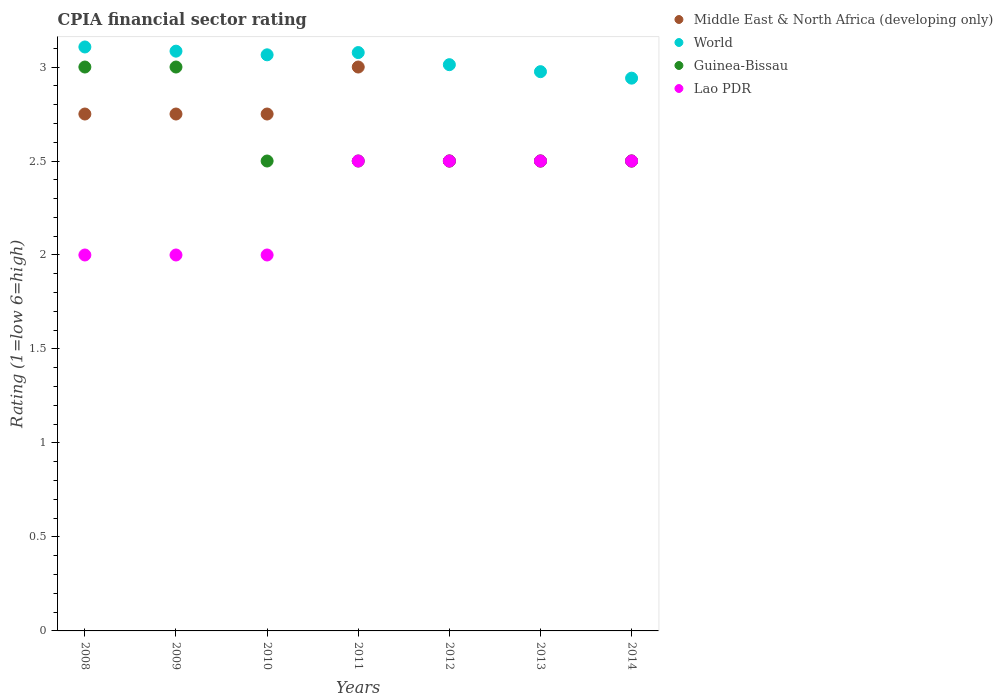How many different coloured dotlines are there?
Your answer should be very brief. 4. Is the number of dotlines equal to the number of legend labels?
Offer a very short reply. Yes. What is the CPIA rating in Lao PDR in 2013?
Provide a succinct answer. 2.5. Across all years, what is the maximum CPIA rating in Guinea-Bissau?
Make the answer very short. 3. Across all years, what is the minimum CPIA rating in Middle East & North Africa (developing only)?
Provide a short and direct response. 2.5. In which year was the CPIA rating in World maximum?
Provide a succinct answer. 2008. In which year was the CPIA rating in Middle East & North Africa (developing only) minimum?
Make the answer very short. 2012. What is the total CPIA rating in Middle East & North Africa (developing only) in the graph?
Ensure brevity in your answer.  18.75. What is the difference between the CPIA rating in Middle East & North Africa (developing only) in 2011 and that in 2014?
Ensure brevity in your answer.  0.5. What is the difference between the CPIA rating in Lao PDR in 2011 and the CPIA rating in Middle East & North Africa (developing only) in 2010?
Make the answer very short. -0.25. What is the average CPIA rating in Lao PDR per year?
Ensure brevity in your answer.  2.29. In the year 2014, what is the difference between the CPIA rating in World and CPIA rating in Lao PDR?
Make the answer very short. 0.44. What is the ratio of the CPIA rating in Guinea-Bissau in 2009 to that in 2011?
Make the answer very short. 1.2. Is the CPIA rating in World in 2009 less than that in 2013?
Provide a succinct answer. No. What is the difference between the highest and the second highest CPIA rating in Lao PDR?
Offer a terse response. 0. What is the difference between the highest and the lowest CPIA rating in Guinea-Bissau?
Offer a terse response. 0.5. Is the CPIA rating in World strictly less than the CPIA rating in Guinea-Bissau over the years?
Offer a very short reply. No. Are the values on the major ticks of Y-axis written in scientific E-notation?
Your response must be concise. No. Where does the legend appear in the graph?
Ensure brevity in your answer.  Top right. What is the title of the graph?
Your response must be concise. CPIA financial sector rating. Does "South Africa" appear as one of the legend labels in the graph?
Keep it short and to the point. No. What is the label or title of the X-axis?
Your response must be concise. Years. What is the label or title of the Y-axis?
Your answer should be very brief. Rating (1=low 6=high). What is the Rating (1=low 6=high) of Middle East & North Africa (developing only) in 2008?
Give a very brief answer. 2.75. What is the Rating (1=low 6=high) in World in 2008?
Ensure brevity in your answer.  3.11. What is the Rating (1=low 6=high) of Guinea-Bissau in 2008?
Your response must be concise. 3. What is the Rating (1=low 6=high) in Lao PDR in 2008?
Offer a very short reply. 2. What is the Rating (1=low 6=high) of Middle East & North Africa (developing only) in 2009?
Keep it short and to the point. 2.75. What is the Rating (1=low 6=high) in World in 2009?
Give a very brief answer. 3.08. What is the Rating (1=low 6=high) in Middle East & North Africa (developing only) in 2010?
Provide a short and direct response. 2.75. What is the Rating (1=low 6=high) in World in 2010?
Give a very brief answer. 3.06. What is the Rating (1=low 6=high) of Lao PDR in 2010?
Your answer should be very brief. 2. What is the Rating (1=low 6=high) of World in 2011?
Your answer should be compact. 3.08. What is the Rating (1=low 6=high) in World in 2012?
Your response must be concise. 3.01. What is the Rating (1=low 6=high) in Middle East & North Africa (developing only) in 2013?
Your answer should be compact. 2.5. What is the Rating (1=low 6=high) in World in 2013?
Provide a succinct answer. 2.98. What is the Rating (1=low 6=high) in Guinea-Bissau in 2013?
Offer a very short reply. 2.5. What is the Rating (1=low 6=high) of Lao PDR in 2013?
Offer a terse response. 2.5. What is the Rating (1=low 6=high) of Middle East & North Africa (developing only) in 2014?
Your answer should be compact. 2.5. What is the Rating (1=low 6=high) in World in 2014?
Your answer should be very brief. 2.94. What is the Rating (1=low 6=high) in Guinea-Bissau in 2014?
Your answer should be very brief. 2.5. Across all years, what is the maximum Rating (1=low 6=high) in Middle East & North Africa (developing only)?
Provide a succinct answer. 3. Across all years, what is the maximum Rating (1=low 6=high) in World?
Keep it short and to the point. 3.11. Across all years, what is the maximum Rating (1=low 6=high) of Guinea-Bissau?
Keep it short and to the point. 3. Across all years, what is the minimum Rating (1=low 6=high) in World?
Offer a terse response. 2.94. Across all years, what is the minimum Rating (1=low 6=high) in Lao PDR?
Give a very brief answer. 2. What is the total Rating (1=low 6=high) of Middle East & North Africa (developing only) in the graph?
Offer a very short reply. 18.75. What is the total Rating (1=low 6=high) in World in the graph?
Offer a very short reply. 21.26. What is the total Rating (1=low 6=high) of Lao PDR in the graph?
Keep it short and to the point. 16. What is the difference between the Rating (1=low 6=high) of World in 2008 and that in 2009?
Ensure brevity in your answer.  0.02. What is the difference between the Rating (1=low 6=high) in Middle East & North Africa (developing only) in 2008 and that in 2010?
Offer a very short reply. 0. What is the difference between the Rating (1=low 6=high) of World in 2008 and that in 2010?
Offer a terse response. 0.04. What is the difference between the Rating (1=low 6=high) of Guinea-Bissau in 2008 and that in 2010?
Keep it short and to the point. 0.5. What is the difference between the Rating (1=low 6=high) in Lao PDR in 2008 and that in 2010?
Provide a succinct answer. 0. What is the difference between the Rating (1=low 6=high) of Middle East & North Africa (developing only) in 2008 and that in 2011?
Provide a short and direct response. -0.25. What is the difference between the Rating (1=low 6=high) in World in 2008 and that in 2011?
Your answer should be very brief. 0.03. What is the difference between the Rating (1=low 6=high) in Guinea-Bissau in 2008 and that in 2011?
Give a very brief answer. 0.5. What is the difference between the Rating (1=low 6=high) in Middle East & North Africa (developing only) in 2008 and that in 2012?
Ensure brevity in your answer.  0.25. What is the difference between the Rating (1=low 6=high) in World in 2008 and that in 2012?
Provide a short and direct response. 0.09. What is the difference between the Rating (1=low 6=high) in Middle East & North Africa (developing only) in 2008 and that in 2013?
Make the answer very short. 0.25. What is the difference between the Rating (1=low 6=high) in World in 2008 and that in 2013?
Provide a succinct answer. 0.13. What is the difference between the Rating (1=low 6=high) of Lao PDR in 2008 and that in 2013?
Ensure brevity in your answer.  -0.5. What is the difference between the Rating (1=low 6=high) in World in 2008 and that in 2014?
Keep it short and to the point. 0.17. What is the difference between the Rating (1=low 6=high) in Lao PDR in 2008 and that in 2014?
Keep it short and to the point. -0.5. What is the difference between the Rating (1=low 6=high) of Middle East & North Africa (developing only) in 2009 and that in 2010?
Keep it short and to the point. 0. What is the difference between the Rating (1=low 6=high) in World in 2009 and that in 2010?
Your answer should be compact. 0.02. What is the difference between the Rating (1=low 6=high) of Middle East & North Africa (developing only) in 2009 and that in 2011?
Provide a short and direct response. -0.25. What is the difference between the Rating (1=low 6=high) in World in 2009 and that in 2011?
Provide a short and direct response. 0.01. What is the difference between the Rating (1=low 6=high) in World in 2009 and that in 2012?
Make the answer very short. 0.07. What is the difference between the Rating (1=low 6=high) in Lao PDR in 2009 and that in 2012?
Your answer should be very brief. -0.5. What is the difference between the Rating (1=low 6=high) in Middle East & North Africa (developing only) in 2009 and that in 2013?
Your answer should be very brief. 0.25. What is the difference between the Rating (1=low 6=high) of World in 2009 and that in 2013?
Provide a short and direct response. 0.11. What is the difference between the Rating (1=low 6=high) in World in 2009 and that in 2014?
Provide a succinct answer. 0.14. What is the difference between the Rating (1=low 6=high) in Guinea-Bissau in 2009 and that in 2014?
Ensure brevity in your answer.  0.5. What is the difference between the Rating (1=low 6=high) in Middle East & North Africa (developing only) in 2010 and that in 2011?
Offer a very short reply. -0.25. What is the difference between the Rating (1=low 6=high) of World in 2010 and that in 2011?
Your answer should be compact. -0.01. What is the difference between the Rating (1=low 6=high) of Lao PDR in 2010 and that in 2011?
Keep it short and to the point. -0.5. What is the difference between the Rating (1=low 6=high) in Middle East & North Africa (developing only) in 2010 and that in 2012?
Your answer should be compact. 0.25. What is the difference between the Rating (1=low 6=high) of World in 2010 and that in 2012?
Make the answer very short. 0.05. What is the difference between the Rating (1=low 6=high) in Lao PDR in 2010 and that in 2012?
Provide a succinct answer. -0.5. What is the difference between the Rating (1=low 6=high) of Middle East & North Africa (developing only) in 2010 and that in 2013?
Offer a very short reply. 0.25. What is the difference between the Rating (1=low 6=high) of World in 2010 and that in 2013?
Offer a terse response. 0.09. What is the difference between the Rating (1=low 6=high) of Guinea-Bissau in 2010 and that in 2013?
Your answer should be very brief. 0. What is the difference between the Rating (1=low 6=high) in Middle East & North Africa (developing only) in 2010 and that in 2014?
Provide a short and direct response. 0.25. What is the difference between the Rating (1=low 6=high) of World in 2010 and that in 2014?
Provide a short and direct response. 0.12. What is the difference between the Rating (1=low 6=high) of Lao PDR in 2010 and that in 2014?
Offer a very short reply. -0.5. What is the difference between the Rating (1=low 6=high) in Middle East & North Africa (developing only) in 2011 and that in 2012?
Offer a terse response. 0.5. What is the difference between the Rating (1=low 6=high) of World in 2011 and that in 2012?
Offer a terse response. 0.06. What is the difference between the Rating (1=low 6=high) in Guinea-Bissau in 2011 and that in 2012?
Keep it short and to the point. 0. What is the difference between the Rating (1=low 6=high) of Middle East & North Africa (developing only) in 2011 and that in 2013?
Ensure brevity in your answer.  0.5. What is the difference between the Rating (1=low 6=high) of World in 2011 and that in 2013?
Provide a succinct answer. 0.1. What is the difference between the Rating (1=low 6=high) of Guinea-Bissau in 2011 and that in 2013?
Your response must be concise. 0. What is the difference between the Rating (1=low 6=high) of Lao PDR in 2011 and that in 2013?
Provide a short and direct response. 0. What is the difference between the Rating (1=low 6=high) of Middle East & North Africa (developing only) in 2011 and that in 2014?
Ensure brevity in your answer.  0.5. What is the difference between the Rating (1=low 6=high) in World in 2011 and that in 2014?
Your response must be concise. 0.14. What is the difference between the Rating (1=low 6=high) of Guinea-Bissau in 2011 and that in 2014?
Offer a very short reply. 0. What is the difference between the Rating (1=low 6=high) in World in 2012 and that in 2013?
Give a very brief answer. 0.04. What is the difference between the Rating (1=low 6=high) in Guinea-Bissau in 2012 and that in 2013?
Keep it short and to the point. 0. What is the difference between the Rating (1=low 6=high) in Lao PDR in 2012 and that in 2013?
Make the answer very short. 0. What is the difference between the Rating (1=low 6=high) in World in 2012 and that in 2014?
Your answer should be compact. 0.07. What is the difference between the Rating (1=low 6=high) of Guinea-Bissau in 2012 and that in 2014?
Your answer should be compact. 0. What is the difference between the Rating (1=low 6=high) of Lao PDR in 2012 and that in 2014?
Your answer should be very brief. 0. What is the difference between the Rating (1=low 6=high) of World in 2013 and that in 2014?
Your response must be concise. 0.03. What is the difference between the Rating (1=low 6=high) in Middle East & North Africa (developing only) in 2008 and the Rating (1=low 6=high) in World in 2009?
Make the answer very short. -0.33. What is the difference between the Rating (1=low 6=high) of Middle East & North Africa (developing only) in 2008 and the Rating (1=low 6=high) of Guinea-Bissau in 2009?
Provide a succinct answer. -0.25. What is the difference between the Rating (1=low 6=high) in World in 2008 and the Rating (1=low 6=high) in Guinea-Bissau in 2009?
Provide a succinct answer. 0.11. What is the difference between the Rating (1=low 6=high) in World in 2008 and the Rating (1=low 6=high) in Lao PDR in 2009?
Your response must be concise. 1.11. What is the difference between the Rating (1=low 6=high) of Guinea-Bissau in 2008 and the Rating (1=low 6=high) of Lao PDR in 2009?
Provide a short and direct response. 1. What is the difference between the Rating (1=low 6=high) of Middle East & North Africa (developing only) in 2008 and the Rating (1=low 6=high) of World in 2010?
Give a very brief answer. -0.31. What is the difference between the Rating (1=low 6=high) in World in 2008 and the Rating (1=low 6=high) in Guinea-Bissau in 2010?
Offer a very short reply. 0.61. What is the difference between the Rating (1=low 6=high) of World in 2008 and the Rating (1=low 6=high) of Lao PDR in 2010?
Offer a very short reply. 1.11. What is the difference between the Rating (1=low 6=high) in Middle East & North Africa (developing only) in 2008 and the Rating (1=low 6=high) in World in 2011?
Offer a very short reply. -0.33. What is the difference between the Rating (1=low 6=high) of World in 2008 and the Rating (1=low 6=high) of Guinea-Bissau in 2011?
Keep it short and to the point. 0.61. What is the difference between the Rating (1=low 6=high) in World in 2008 and the Rating (1=low 6=high) in Lao PDR in 2011?
Give a very brief answer. 0.61. What is the difference between the Rating (1=low 6=high) in Middle East & North Africa (developing only) in 2008 and the Rating (1=low 6=high) in World in 2012?
Offer a very short reply. -0.26. What is the difference between the Rating (1=low 6=high) of Middle East & North Africa (developing only) in 2008 and the Rating (1=low 6=high) of Lao PDR in 2012?
Provide a short and direct response. 0.25. What is the difference between the Rating (1=low 6=high) in World in 2008 and the Rating (1=low 6=high) in Guinea-Bissau in 2012?
Provide a succinct answer. 0.61. What is the difference between the Rating (1=low 6=high) in World in 2008 and the Rating (1=low 6=high) in Lao PDR in 2012?
Make the answer very short. 0.61. What is the difference between the Rating (1=low 6=high) in Middle East & North Africa (developing only) in 2008 and the Rating (1=low 6=high) in World in 2013?
Ensure brevity in your answer.  -0.23. What is the difference between the Rating (1=low 6=high) of World in 2008 and the Rating (1=low 6=high) of Guinea-Bissau in 2013?
Your answer should be compact. 0.61. What is the difference between the Rating (1=low 6=high) in World in 2008 and the Rating (1=low 6=high) in Lao PDR in 2013?
Provide a succinct answer. 0.61. What is the difference between the Rating (1=low 6=high) of Guinea-Bissau in 2008 and the Rating (1=low 6=high) of Lao PDR in 2013?
Give a very brief answer. 0.5. What is the difference between the Rating (1=low 6=high) in Middle East & North Africa (developing only) in 2008 and the Rating (1=low 6=high) in World in 2014?
Give a very brief answer. -0.19. What is the difference between the Rating (1=low 6=high) in Middle East & North Africa (developing only) in 2008 and the Rating (1=low 6=high) in Guinea-Bissau in 2014?
Make the answer very short. 0.25. What is the difference between the Rating (1=low 6=high) in World in 2008 and the Rating (1=low 6=high) in Guinea-Bissau in 2014?
Your response must be concise. 0.61. What is the difference between the Rating (1=low 6=high) of World in 2008 and the Rating (1=low 6=high) of Lao PDR in 2014?
Give a very brief answer. 0.61. What is the difference between the Rating (1=low 6=high) in Middle East & North Africa (developing only) in 2009 and the Rating (1=low 6=high) in World in 2010?
Provide a succinct answer. -0.31. What is the difference between the Rating (1=low 6=high) in Middle East & North Africa (developing only) in 2009 and the Rating (1=low 6=high) in Guinea-Bissau in 2010?
Provide a succinct answer. 0.25. What is the difference between the Rating (1=low 6=high) in World in 2009 and the Rating (1=low 6=high) in Guinea-Bissau in 2010?
Keep it short and to the point. 0.58. What is the difference between the Rating (1=low 6=high) in World in 2009 and the Rating (1=low 6=high) in Lao PDR in 2010?
Give a very brief answer. 1.08. What is the difference between the Rating (1=low 6=high) of Guinea-Bissau in 2009 and the Rating (1=low 6=high) of Lao PDR in 2010?
Your answer should be very brief. 1. What is the difference between the Rating (1=low 6=high) in Middle East & North Africa (developing only) in 2009 and the Rating (1=low 6=high) in World in 2011?
Your response must be concise. -0.33. What is the difference between the Rating (1=low 6=high) of Middle East & North Africa (developing only) in 2009 and the Rating (1=low 6=high) of Lao PDR in 2011?
Your answer should be very brief. 0.25. What is the difference between the Rating (1=low 6=high) in World in 2009 and the Rating (1=low 6=high) in Guinea-Bissau in 2011?
Provide a short and direct response. 0.58. What is the difference between the Rating (1=low 6=high) in World in 2009 and the Rating (1=low 6=high) in Lao PDR in 2011?
Offer a terse response. 0.58. What is the difference between the Rating (1=low 6=high) in Middle East & North Africa (developing only) in 2009 and the Rating (1=low 6=high) in World in 2012?
Ensure brevity in your answer.  -0.26. What is the difference between the Rating (1=low 6=high) in Middle East & North Africa (developing only) in 2009 and the Rating (1=low 6=high) in Guinea-Bissau in 2012?
Make the answer very short. 0.25. What is the difference between the Rating (1=low 6=high) in Middle East & North Africa (developing only) in 2009 and the Rating (1=low 6=high) in Lao PDR in 2012?
Ensure brevity in your answer.  0.25. What is the difference between the Rating (1=low 6=high) of World in 2009 and the Rating (1=low 6=high) of Guinea-Bissau in 2012?
Your response must be concise. 0.58. What is the difference between the Rating (1=low 6=high) of World in 2009 and the Rating (1=low 6=high) of Lao PDR in 2012?
Offer a terse response. 0.58. What is the difference between the Rating (1=low 6=high) of Guinea-Bissau in 2009 and the Rating (1=low 6=high) of Lao PDR in 2012?
Ensure brevity in your answer.  0.5. What is the difference between the Rating (1=low 6=high) of Middle East & North Africa (developing only) in 2009 and the Rating (1=low 6=high) of World in 2013?
Make the answer very short. -0.23. What is the difference between the Rating (1=low 6=high) of World in 2009 and the Rating (1=low 6=high) of Guinea-Bissau in 2013?
Your answer should be compact. 0.58. What is the difference between the Rating (1=low 6=high) in World in 2009 and the Rating (1=low 6=high) in Lao PDR in 2013?
Ensure brevity in your answer.  0.58. What is the difference between the Rating (1=low 6=high) in Middle East & North Africa (developing only) in 2009 and the Rating (1=low 6=high) in World in 2014?
Offer a very short reply. -0.19. What is the difference between the Rating (1=low 6=high) of Middle East & North Africa (developing only) in 2009 and the Rating (1=low 6=high) of Guinea-Bissau in 2014?
Your response must be concise. 0.25. What is the difference between the Rating (1=low 6=high) of World in 2009 and the Rating (1=low 6=high) of Guinea-Bissau in 2014?
Keep it short and to the point. 0.58. What is the difference between the Rating (1=low 6=high) of World in 2009 and the Rating (1=low 6=high) of Lao PDR in 2014?
Your answer should be very brief. 0.58. What is the difference between the Rating (1=low 6=high) of Guinea-Bissau in 2009 and the Rating (1=low 6=high) of Lao PDR in 2014?
Offer a terse response. 0.5. What is the difference between the Rating (1=low 6=high) of Middle East & North Africa (developing only) in 2010 and the Rating (1=low 6=high) of World in 2011?
Provide a short and direct response. -0.33. What is the difference between the Rating (1=low 6=high) in Middle East & North Africa (developing only) in 2010 and the Rating (1=low 6=high) in Guinea-Bissau in 2011?
Provide a short and direct response. 0.25. What is the difference between the Rating (1=low 6=high) of Middle East & North Africa (developing only) in 2010 and the Rating (1=low 6=high) of Lao PDR in 2011?
Provide a short and direct response. 0.25. What is the difference between the Rating (1=low 6=high) of World in 2010 and the Rating (1=low 6=high) of Guinea-Bissau in 2011?
Your answer should be very brief. 0.56. What is the difference between the Rating (1=low 6=high) in World in 2010 and the Rating (1=low 6=high) in Lao PDR in 2011?
Offer a terse response. 0.56. What is the difference between the Rating (1=low 6=high) in Guinea-Bissau in 2010 and the Rating (1=low 6=high) in Lao PDR in 2011?
Your answer should be compact. 0. What is the difference between the Rating (1=low 6=high) of Middle East & North Africa (developing only) in 2010 and the Rating (1=low 6=high) of World in 2012?
Offer a very short reply. -0.26. What is the difference between the Rating (1=low 6=high) of Middle East & North Africa (developing only) in 2010 and the Rating (1=low 6=high) of Guinea-Bissau in 2012?
Your response must be concise. 0.25. What is the difference between the Rating (1=low 6=high) in Middle East & North Africa (developing only) in 2010 and the Rating (1=low 6=high) in Lao PDR in 2012?
Provide a short and direct response. 0.25. What is the difference between the Rating (1=low 6=high) in World in 2010 and the Rating (1=low 6=high) in Guinea-Bissau in 2012?
Provide a short and direct response. 0.56. What is the difference between the Rating (1=low 6=high) in World in 2010 and the Rating (1=low 6=high) in Lao PDR in 2012?
Make the answer very short. 0.56. What is the difference between the Rating (1=low 6=high) of Middle East & North Africa (developing only) in 2010 and the Rating (1=low 6=high) of World in 2013?
Offer a very short reply. -0.23. What is the difference between the Rating (1=low 6=high) in Middle East & North Africa (developing only) in 2010 and the Rating (1=low 6=high) in Guinea-Bissau in 2013?
Provide a succinct answer. 0.25. What is the difference between the Rating (1=low 6=high) of World in 2010 and the Rating (1=low 6=high) of Guinea-Bissau in 2013?
Your response must be concise. 0.56. What is the difference between the Rating (1=low 6=high) of World in 2010 and the Rating (1=low 6=high) of Lao PDR in 2013?
Keep it short and to the point. 0.56. What is the difference between the Rating (1=low 6=high) of Guinea-Bissau in 2010 and the Rating (1=low 6=high) of Lao PDR in 2013?
Provide a short and direct response. 0. What is the difference between the Rating (1=low 6=high) in Middle East & North Africa (developing only) in 2010 and the Rating (1=low 6=high) in World in 2014?
Keep it short and to the point. -0.19. What is the difference between the Rating (1=low 6=high) of Middle East & North Africa (developing only) in 2010 and the Rating (1=low 6=high) of Guinea-Bissau in 2014?
Offer a terse response. 0.25. What is the difference between the Rating (1=low 6=high) in World in 2010 and the Rating (1=low 6=high) in Guinea-Bissau in 2014?
Give a very brief answer. 0.56. What is the difference between the Rating (1=low 6=high) in World in 2010 and the Rating (1=low 6=high) in Lao PDR in 2014?
Offer a very short reply. 0.56. What is the difference between the Rating (1=low 6=high) of Middle East & North Africa (developing only) in 2011 and the Rating (1=low 6=high) of World in 2012?
Make the answer very short. -0.01. What is the difference between the Rating (1=low 6=high) of World in 2011 and the Rating (1=low 6=high) of Guinea-Bissau in 2012?
Provide a short and direct response. 0.58. What is the difference between the Rating (1=low 6=high) in World in 2011 and the Rating (1=low 6=high) in Lao PDR in 2012?
Your answer should be compact. 0.58. What is the difference between the Rating (1=low 6=high) of Guinea-Bissau in 2011 and the Rating (1=low 6=high) of Lao PDR in 2012?
Keep it short and to the point. 0. What is the difference between the Rating (1=low 6=high) in Middle East & North Africa (developing only) in 2011 and the Rating (1=low 6=high) in World in 2013?
Keep it short and to the point. 0.02. What is the difference between the Rating (1=low 6=high) of World in 2011 and the Rating (1=low 6=high) of Guinea-Bissau in 2013?
Offer a terse response. 0.58. What is the difference between the Rating (1=low 6=high) of World in 2011 and the Rating (1=low 6=high) of Lao PDR in 2013?
Offer a terse response. 0.58. What is the difference between the Rating (1=low 6=high) in Guinea-Bissau in 2011 and the Rating (1=low 6=high) in Lao PDR in 2013?
Offer a very short reply. 0. What is the difference between the Rating (1=low 6=high) in Middle East & North Africa (developing only) in 2011 and the Rating (1=low 6=high) in World in 2014?
Your response must be concise. 0.06. What is the difference between the Rating (1=low 6=high) in Middle East & North Africa (developing only) in 2011 and the Rating (1=low 6=high) in Guinea-Bissau in 2014?
Your answer should be very brief. 0.5. What is the difference between the Rating (1=low 6=high) in Middle East & North Africa (developing only) in 2011 and the Rating (1=low 6=high) in Lao PDR in 2014?
Keep it short and to the point. 0.5. What is the difference between the Rating (1=low 6=high) of World in 2011 and the Rating (1=low 6=high) of Guinea-Bissau in 2014?
Offer a very short reply. 0.58. What is the difference between the Rating (1=low 6=high) of World in 2011 and the Rating (1=low 6=high) of Lao PDR in 2014?
Give a very brief answer. 0.58. What is the difference between the Rating (1=low 6=high) of Middle East & North Africa (developing only) in 2012 and the Rating (1=low 6=high) of World in 2013?
Your answer should be very brief. -0.48. What is the difference between the Rating (1=low 6=high) in Middle East & North Africa (developing only) in 2012 and the Rating (1=low 6=high) in Guinea-Bissau in 2013?
Ensure brevity in your answer.  0. What is the difference between the Rating (1=low 6=high) in World in 2012 and the Rating (1=low 6=high) in Guinea-Bissau in 2013?
Provide a succinct answer. 0.51. What is the difference between the Rating (1=low 6=high) in World in 2012 and the Rating (1=low 6=high) in Lao PDR in 2013?
Your response must be concise. 0.51. What is the difference between the Rating (1=low 6=high) in Middle East & North Africa (developing only) in 2012 and the Rating (1=low 6=high) in World in 2014?
Your answer should be very brief. -0.44. What is the difference between the Rating (1=low 6=high) of Middle East & North Africa (developing only) in 2012 and the Rating (1=low 6=high) of Lao PDR in 2014?
Your answer should be compact. 0. What is the difference between the Rating (1=low 6=high) in World in 2012 and the Rating (1=low 6=high) in Guinea-Bissau in 2014?
Provide a short and direct response. 0.51. What is the difference between the Rating (1=low 6=high) in World in 2012 and the Rating (1=low 6=high) in Lao PDR in 2014?
Provide a short and direct response. 0.51. What is the difference between the Rating (1=low 6=high) of Guinea-Bissau in 2012 and the Rating (1=low 6=high) of Lao PDR in 2014?
Offer a very short reply. 0. What is the difference between the Rating (1=low 6=high) of Middle East & North Africa (developing only) in 2013 and the Rating (1=low 6=high) of World in 2014?
Offer a very short reply. -0.44. What is the difference between the Rating (1=low 6=high) of Middle East & North Africa (developing only) in 2013 and the Rating (1=low 6=high) of Guinea-Bissau in 2014?
Your response must be concise. 0. What is the difference between the Rating (1=low 6=high) in Middle East & North Africa (developing only) in 2013 and the Rating (1=low 6=high) in Lao PDR in 2014?
Offer a terse response. 0. What is the difference between the Rating (1=low 6=high) of World in 2013 and the Rating (1=low 6=high) of Guinea-Bissau in 2014?
Offer a terse response. 0.48. What is the difference between the Rating (1=low 6=high) of World in 2013 and the Rating (1=low 6=high) of Lao PDR in 2014?
Your answer should be very brief. 0.48. What is the average Rating (1=low 6=high) in Middle East & North Africa (developing only) per year?
Keep it short and to the point. 2.68. What is the average Rating (1=low 6=high) of World per year?
Provide a succinct answer. 3.04. What is the average Rating (1=low 6=high) of Guinea-Bissau per year?
Your answer should be very brief. 2.64. What is the average Rating (1=low 6=high) of Lao PDR per year?
Give a very brief answer. 2.29. In the year 2008, what is the difference between the Rating (1=low 6=high) in Middle East & North Africa (developing only) and Rating (1=low 6=high) in World?
Your answer should be very brief. -0.36. In the year 2008, what is the difference between the Rating (1=low 6=high) in Middle East & North Africa (developing only) and Rating (1=low 6=high) in Guinea-Bissau?
Your response must be concise. -0.25. In the year 2008, what is the difference between the Rating (1=low 6=high) of Middle East & North Africa (developing only) and Rating (1=low 6=high) of Lao PDR?
Offer a terse response. 0.75. In the year 2008, what is the difference between the Rating (1=low 6=high) in World and Rating (1=low 6=high) in Guinea-Bissau?
Offer a terse response. 0.11. In the year 2008, what is the difference between the Rating (1=low 6=high) in World and Rating (1=low 6=high) in Lao PDR?
Give a very brief answer. 1.11. In the year 2008, what is the difference between the Rating (1=low 6=high) of Guinea-Bissau and Rating (1=low 6=high) of Lao PDR?
Make the answer very short. 1. In the year 2009, what is the difference between the Rating (1=low 6=high) in Middle East & North Africa (developing only) and Rating (1=low 6=high) in World?
Keep it short and to the point. -0.33. In the year 2009, what is the difference between the Rating (1=low 6=high) in World and Rating (1=low 6=high) in Guinea-Bissau?
Provide a succinct answer. 0.08. In the year 2009, what is the difference between the Rating (1=low 6=high) in World and Rating (1=low 6=high) in Lao PDR?
Give a very brief answer. 1.08. In the year 2010, what is the difference between the Rating (1=low 6=high) in Middle East & North Africa (developing only) and Rating (1=low 6=high) in World?
Your answer should be compact. -0.31. In the year 2010, what is the difference between the Rating (1=low 6=high) of World and Rating (1=low 6=high) of Guinea-Bissau?
Your answer should be very brief. 0.56. In the year 2010, what is the difference between the Rating (1=low 6=high) in World and Rating (1=low 6=high) in Lao PDR?
Give a very brief answer. 1.06. In the year 2010, what is the difference between the Rating (1=low 6=high) of Guinea-Bissau and Rating (1=low 6=high) of Lao PDR?
Provide a succinct answer. 0.5. In the year 2011, what is the difference between the Rating (1=low 6=high) of Middle East & North Africa (developing only) and Rating (1=low 6=high) of World?
Make the answer very short. -0.08. In the year 2011, what is the difference between the Rating (1=low 6=high) of Middle East & North Africa (developing only) and Rating (1=low 6=high) of Guinea-Bissau?
Your answer should be very brief. 0.5. In the year 2011, what is the difference between the Rating (1=low 6=high) of World and Rating (1=low 6=high) of Guinea-Bissau?
Offer a very short reply. 0.58. In the year 2011, what is the difference between the Rating (1=low 6=high) in World and Rating (1=low 6=high) in Lao PDR?
Offer a very short reply. 0.58. In the year 2011, what is the difference between the Rating (1=low 6=high) of Guinea-Bissau and Rating (1=low 6=high) of Lao PDR?
Your response must be concise. 0. In the year 2012, what is the difference between the Rating (1=low 6=high) in Middle East & North Africa (developing only) and Rating (1=low 6=high) in World?
Offer a very short reply. -0.51. In the year 2012, what is the difference between the Rating (1=low 6=high) in Middle East & North Africa (developing only) and Rating (1=low 6=high) in Lao PDR?
Provide a short and direct response. 0. In the year 2012, what is the difference between the Rating (1=low 6=high) in World and Rating (1=low 6=high) in Guinea-Bissau?
Your answer should be compact. 0.51. In the year 2012, what is the difference between the Rating (1=low 6=high) in World and Rating (1=low 6=high) in Lao PDR?
Your answer should be very brief. 0.51. In the year 2013, what is the difference between the Rating (1=low 6=high) of Middle East & North Africa (developing only) and Rating (1=low 6=high) of World?
Your answer should be compact. -0.48. In the year 2013, what is the difference between the Rating (1=low 6=high) of Middle East & North Africa (developing only) and Rating (1=low 6=high) of Guinea-Bissau?
Ensure brevity in your answer.  0. In the year 2013, what is the difference between the Rating (1=low 6=high) in Middle East & North Africa (developing only) and Rating (1=low 6=high) in Lao PDR?
Your answer should be very brief. 0. In the year 2013, what is the difference between the Rating (1=low 6=high) of World and Rating (1=low 6=high) of Guinea-Bissau?
Your answer should be compact. 0.48. In the year 2013, what is the difference between the Rating (1=low 6=high) of World and Rating (1=low 6=high) of Lao PDR?
Your answer should be very brief. 0.48. In the year 2014, what is the difference between the Rating (1=low 6=high) in Middle East & North Africa (developing only) and Rating (1=low 6=high) in World?
Offer a very short reply. -0.44. In the year 2014, what is the difference between the Rating (1=low 6=high) in Middle East & North Africa (developing only) and Rating (1=low 6=high) in Lao PDR?
Your response must be concise. 0. In the year 2014, what is the difference between the Rating (1=low 6=high) in World and Rating (1=low 6=high) in Guinea-Bissau?
Offer a very short reply. 0.44. In the year 2014, what is the difference between the Rating (1=low 6=high) in World and Rating (1=low 6=high) in Lao PDR?
Ensure brevity in your answer.  0.44. In the year 2014, what is the difference between the Rating (1=low 6=high) of Guinea-Bissau and Rating (1=low 6=high) of Lao PDR?
Keep it short and to the point. 0. What is the ratio of the Rating (1=low 6=high) of Middle East & North Africa (developing only) in 2008 to that in 2009?
Offer a very short reply. 1. What is the ratio of the Rating (1=low 6=high) of Lao PDR in 2008 to that in 2009?
Ensure brevity in your answer.  1. What is the ratio of the Rating (1=low 6=high) of Middle East & North Africa (developing only) in 2008 to that in 2010?
Keep it short and to the point. 1. What is the ratio of the Rating (1=low 6=high) of World in 2008 to that in 2010?
Make the answer very short. 1.01. What is the ratio of the Rating (1=low 6=high) in Guinea-Bissau in 2008 to that in 2010?
Offer a very short reply. 1.2. What is the ratio of the Rating (1=low 6=high) in Lao PDR in 2008 to that in 2010?
Provide a succinct answer. 1. What is the ratio of the Rating (1=low 6=high) of World in 2008 to that in 2011?
Offer a very short reply. 1.01. What is the ratio of the Rating (1=low 6=high) in Guinea-Bissau in 2008 to that in 2011?
Your response must be concise. 1.2. What is the ratio of the Rating (1=low 6=high) of World in 2008 to that in 2012?
Ensure brevity in your answer.  1.03. What is the ratio of the Rating (1=low 6=high) in Guinea-Bissau in 2008 to that in 2012?
Your answer should be compact. 1.2. What is the ratio of the Rating (1=low 6=high) in World in 2008 to that in 2013?
Provide a short and direct response. 1.04. What is the ratio of the Rating (1=low 6=high) in Guinea-Bissau in 2008 to that in 2013?
Keep it short and to the point. 1.2. What is the ratio of the Rating (1=low 6=high) in Lao PDR in 2008 to that in 2013?
Ensure brevity in your answer.  0.8. What is the ratio of the Rating (1=low 6=high) in Middle East & North Africa (developing only) in 2008 to that in 2014?
Keep it short and to the point. 1.1. What is the ratio of the Rating (1=low 6=high) of World in 2008 to that in 2014?
Your response must be concise. 1.06. What is the ratio of the Rating (1=low 6=high) in World in 2009 to that in 2010?
Your response must be concise. 1.01. What is the ratio of the Rating (1=low 6=high) of Guinea-Bissau in 2009 to that in 2010?
Give a very brief answer. 1.2. What is the ratio of the Rating (1=low 6=high) in Lao PDR in 2009 to that in 2010?
Provide a short and direct response. 1. What is the ratio of the Rating (1=low 6=high) in Middle East & North Africa (developing only) in 2009 to that in 2011?
Your answer should be very brief. 0.92. What is the ratio of the Rating (1=low 6=high) in World in 2009 to that in 2011?
Provide a succinct answer. 1. What is the ratio of the Rating (1=low 6=high) in Guinea-Bissau in 2009 to that in 2011?
Make the answer very short. 1.2. What is the ratio of the Rating (1=low 6=high) in Middle East & North Africa (developing only) in 2009 to that in 2012?
Offer a very short reply. 1.1. What is the ratio of the Rating (1=low 6=high) in World in 2009 to that in 2012?
Give a very brief answer. 1.02. What is the ratio of the Rating (1=low 6=high) in Lao PDR in 2009 to that in 2012?
Give a very brief answer. 0.8. What is the ratio of the Rating (1=low 6=high) of Middle East & North Africa (developing only) in 2009 to that in 2013?
Give a very brief answer. 1.1. What is the ratio of the Rating (1=low 6=high) of World in 2009 to that in 2013?
Provide a succinct answer. 1.04. What is the ratio of the Rating (1=low 6=high) in Lao PDR in 2009 to that in 2013?
Your answer should be very brief. 0.8. What is the ratio of the Rating (1=low 6=high) in Middle East & North Africa (developing only) in 2009 to that in 2014?
Make the answer very short. 1.1. What is the ratio of the Rating (1=low 6=high) of World in 2009 to that in 2014?
Keep it short and to the point. 1.05. What is the ratio of the Rating (1=low 6=high) of Middle East & North Africa (developing only) in 2010 to that in 2011?
Offer a terse response. 0.92. What is the ratio of the Rating (1=low 6=high) in World in 2010 to that in 2011?
Your response must be concise. 1. What is the ratio of the Rating (1=low 6=high) of Lao PDR in 2010 to that in 2011?
Your response must be concise. 0.8. What is the ratio of the Rating (1=low 6=high) in Middle East & North Africa (developing only) in 2010 to that in 2012?
Ensure brevity in your answer.  1.1. What is the ratio of the Rating (1=low 6=high) in World in 2010 to that in 2012?
Provide a succinct answer. 1.02. What is the ratio of the Rating (1=low 6=high) of Guinea-Bissau in 2010 to that in 2012?
Offer a terse response. 1. What is the ratio of the Rating (1=low 6=high) in World in 2010 to that in 2013?
Keep it short and to the point. 1.03. What is the ratio of the Rating (1=low 6=high) in Lao PDR in 2010 to that in 2013?
Ensure brevity in your answer.  0.8. What is the ratio of the Rating (1=low 6=high) of Middle East & North Africa (developing only) in 2010 to that in 2014?
Your response must be concise. 1.1. What is the ratio of the Rating (1=low 6=high) of World in 2010 to that in 2014?
Your response must be concise. 1.04. What is the ratio of the Rating (1=low 6=high) in Guinea-Bissau in 2010 to that in 2014?
Ensure brevity in your answer.  1. What is the ratio of the Rating (1=low 6=high) of Lao PDR in 2010 to that in 2014?
Offer a terse response. 0.8. What is the ratio of the Rating (1=low 6=high) in World in 2011 to that in 2012?
Provide a succinct answer. 1.02. What is the ratio of the Rating (1=low 6=high) in Lao PDR in 2011 to that in 2012?
Provide a succinct answer. 1. What is the ratio of the Rating (1=low 6=high) in World in 2011 to that in 2013?
Give a very brief answer. 1.03. What is the ratio of the Rating (1=low 6=high) of Guinea-Bissau in 2011 to that in 2013?
Your response must be concise. 1. What is the ratio of the Rating (1=low 6=high) of Lao PDR in 2011 to that in 2013?
Offer a terse response. 1. What is the ratio of the Rating (1=low 6=high) of World in 2011 to that in 2014?
Offer a very short reply. 1.05. What is the ratio of the Rating (1=low 6=high) of Lao PDR in 2011 to that in 2014?
Provide a short and direct response. 1. What is the ratio of the Rating (1=low 6=high) of World in 2012 to that in 2013?
Your response must be concise. 1.01. What is the ratio of the Rating (1=low 6=high) in Middle East & North Africa (developing only) in 2012 to that in 2014?
Make the answer very short. 1. What is the ratio of the Rating (1=low 6=high) of World in 2012 to that in 2014?
Your answer should be very brief. 1.02. What is the ratio of the Rating (1=low 6=high) of Middle East & North Africa (developing only) in 2013 to that in 2014?
Provide a succinct answer. 1. What is the ratio of the Rating (1=low 6=high) of World in 2013 to that in 2014?
Provide a short and direct response. 1.01. What is the ratio of the Rating (1=low 6=high) in Guinea-Bissau in 2013 to that in 2014?
Offer a very short reply. 1. What is the ratio of the Rating (1=low 6=high) in Lao PDR in 2013 to that in 2014?
Keep it short and to the point. 1. What is the difference between the highest and the second highest Rating (1=low 6=high) in World?
Your answer should be compact. 0.02. What is the difference between the highest and the lowest Rating (1=low 6=high) of Middle East & North Africa (developing only)?
Keep it short and to the point. 0.5. What is the difference between the highest and the lowest Rating (1=low 6=high) of World?
Your response must be concise. 0.17. 